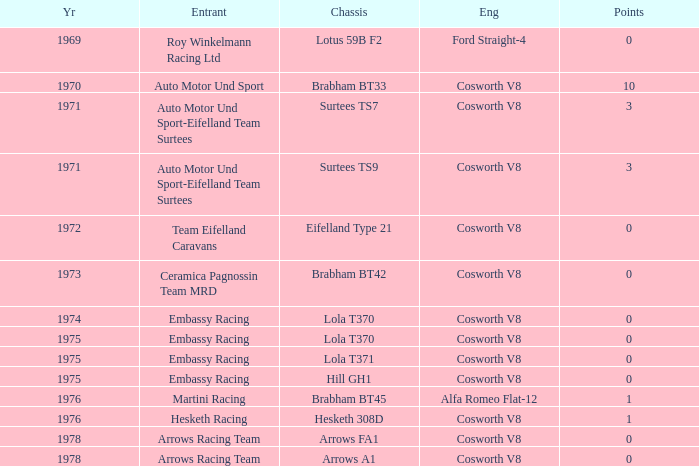Who was the entrant in 1971? Auto Motor Und Sport-Eifelland Team Surtees, Auto Motor Und Sport-Eifelland Team Surtees. 